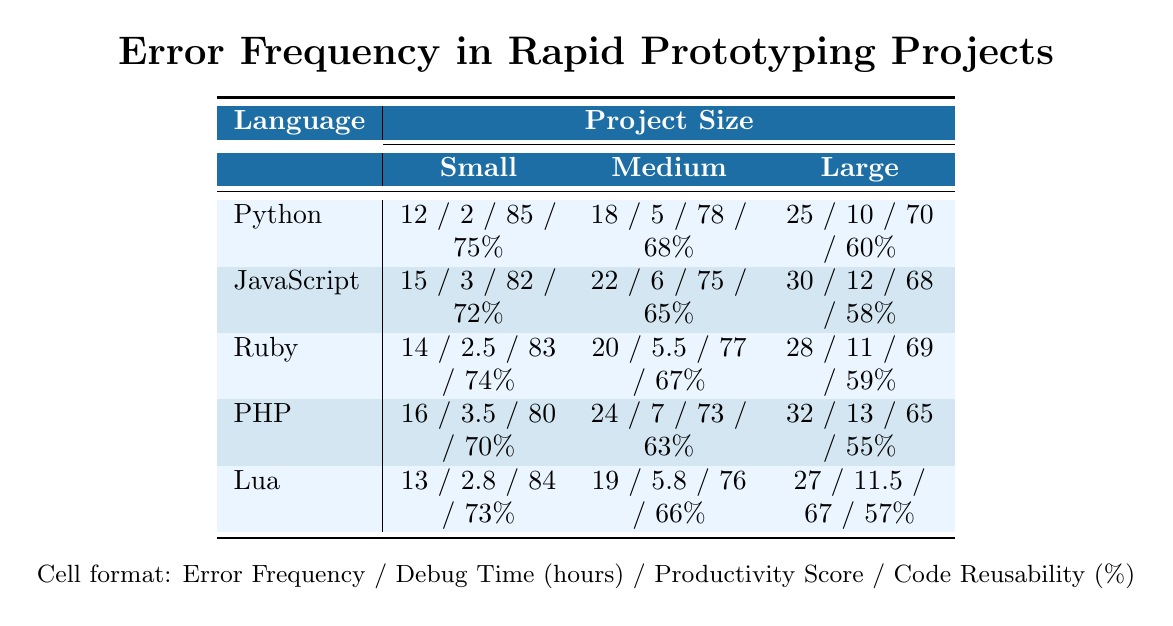What is the error frequency for JavaScript in medium-sized projects? Referring to the table, the error frequency for JavaScript when working on a medium-sized project is 22.
Answer: 22 Which language has the highest productivity score for small projects? Looking at the table, Python has the highest productivity score of 85 for small projects.
Answer: Python What is the average debug time for large projects across all languages? To find the average debug time for large projects, sum the debug times: 10 + 12 + 11 + 13 + 11.5 = 67.5. Divide by 5 (number of languages): 67.5/5 = 13.5.
Answer: 13.5 Is the code reusability percentage for Ruby in large projects greater than that for PHP? Ruby's code reusability percentage for large projects is 59%, and PHP's is 55%. Since 59% > 55%, the statement is true.
Answer: Yes What is the difference in error frequency between the largest and smallest project sizes for Python? The error frequency for Python in large projects is 25, and for small projects, it is 12. The difference is 25 - 12 = 13.
Answer: 13 Which programming language has the least error frequency in small projects? By comparing the error frequencies for small projects, Python has 12, JavaScript has 15, Ruby has 14, PHP has 16, and Lua has 13. The least is Python with 12.
Answer: Python If the productivity scores for JavaScript and PHP are combined, what is the total for medium projects? For medium projects, JavaScript's productivity score is 75 and PHP's is 73. Thus, the total is 75 + 73 = 148.
Answer: 148 What is the least debug time for medium projects among the languages listed? Reviewing the debug times for medium projects reveals: Python 5, JavaScript 6, Ruby 5.5, PHP 7, and Lua 5.8. The least is Python with 5 hours.
Answer: Python Which programming language shows the highest code reusability percentage for large projects? In large projects, the code reusability percentages are: Python 60%, JavaScript 58%, Ruby 59%, PHP 55%, and Lua 57%. The highest is Python with 60%.
Answer: Python What is the combined error frequency for small projects from all programming languages? The combined error frequency for small projects is calculated as follows: 12 (Python) + 15 (JavaScript) + 14 (Ruby) + 16 (PHP) + 13 (Lua) = 70.
Answer: 70 